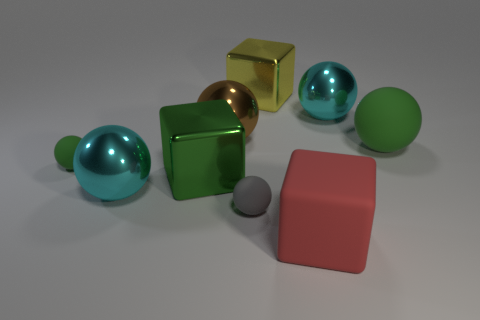Subtract all gray spheres. How many spheres are left? 5 Subtract all green matte balls. How many balls are left? 4 Subtract 3 balls. How many balls are left? 3 Subtract all red spheres. Subtract all gray cylinders. How many spheres are left? 6 Add 1 yellow metal things. How many objects exist? 10 Subtract all blocks. How many objects are left? 6 Add 2 small rubber spheres. How many small rubber spheres are left? 4 Add 5 brown metallic blocks. How many brown metallic blocks exist? 5 Subtract 0 red cylinders. How many objects are left? 9 Subtract all tiny matte things. Subtract all big yellow shiny blocks. How many objects are left? 6 